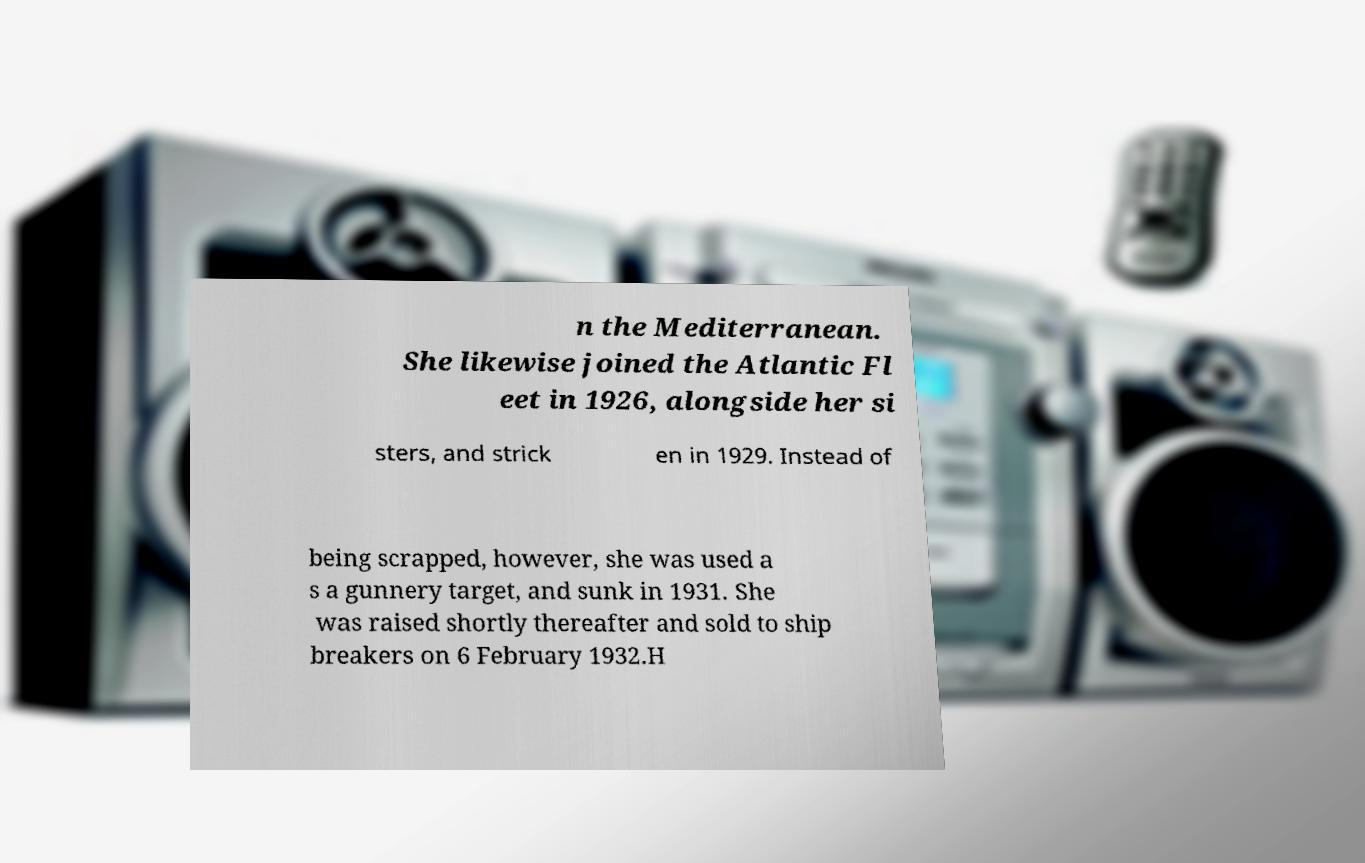What messages or text are displayed in this image? I need them in a readable, typed format. n the Mediterranean. She likewise joined the Atlantic Fl eet in 1926, alongside her si sters, and strick en in 1929. Instead of being scrapped, however, she was used a s a gunnery target, and sunk in 1931. She was raised shortly thereafter and sold to ship breakers on 6 February 1932.H 